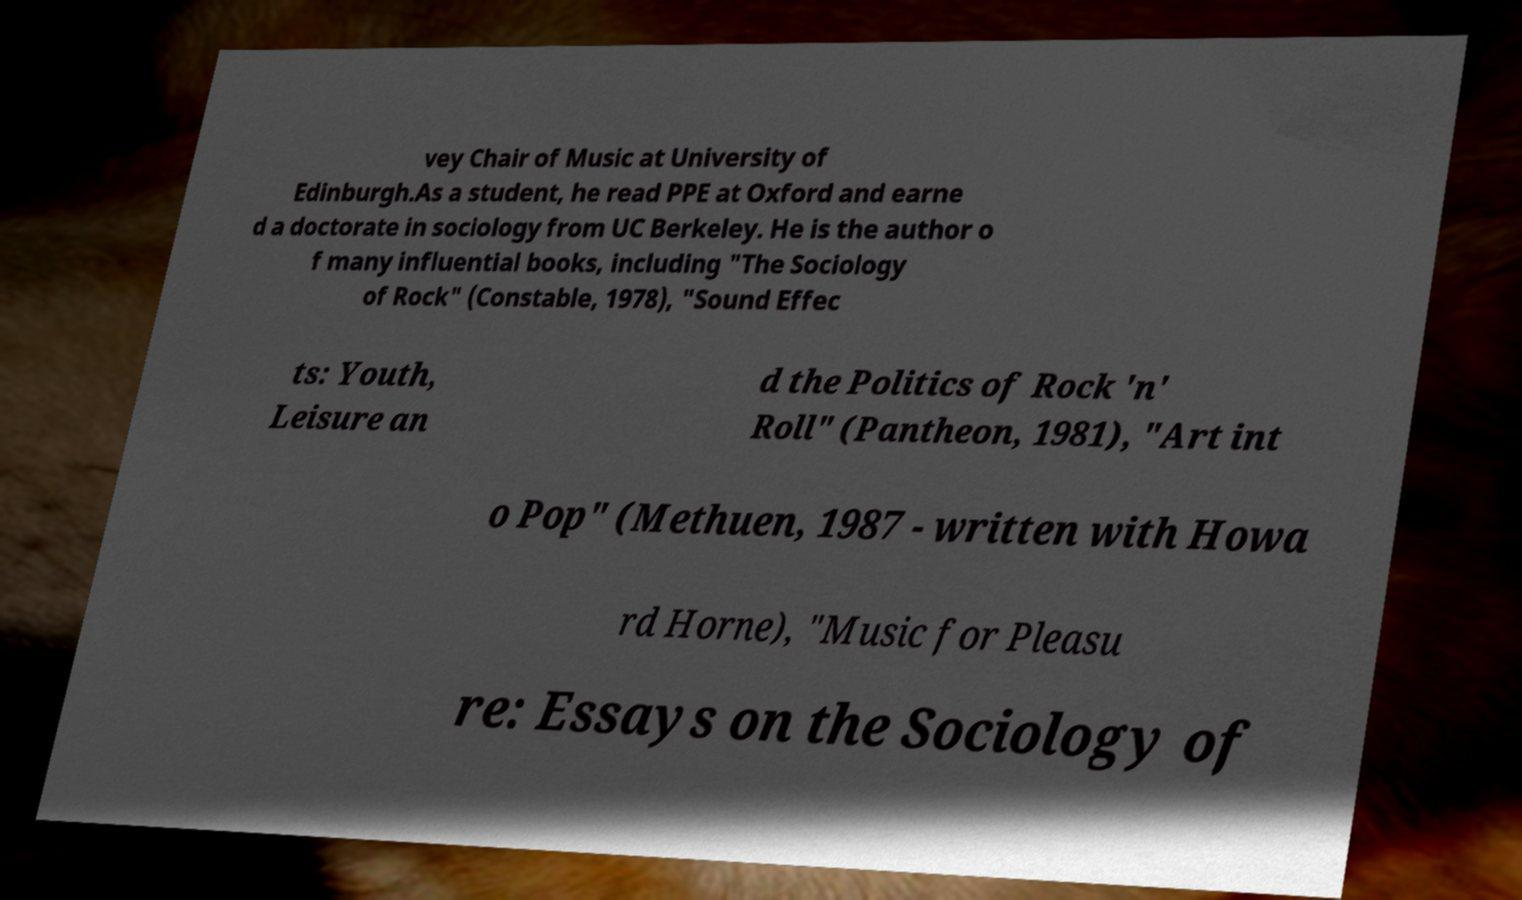What messages or text are displayed in this image? I need them in a readable, typed format. vey Chair of Music at University of Edinburgh.As a student, he read PPE at Oxford and earne d a doctorate in sociology from UC Berkeley. He is the author o f many influential books, including "The Sociology of Rock" (Constable, 1978), "Sound Effec ts: Youth, Leisure an d the Politics of Rock 'n' Roll" (Pantheon, 1981), "Art int o Pop" (Methuen, 1987 - written with Howa rd Horne), "Music for Pleasu re: Essays on the Sociology of 